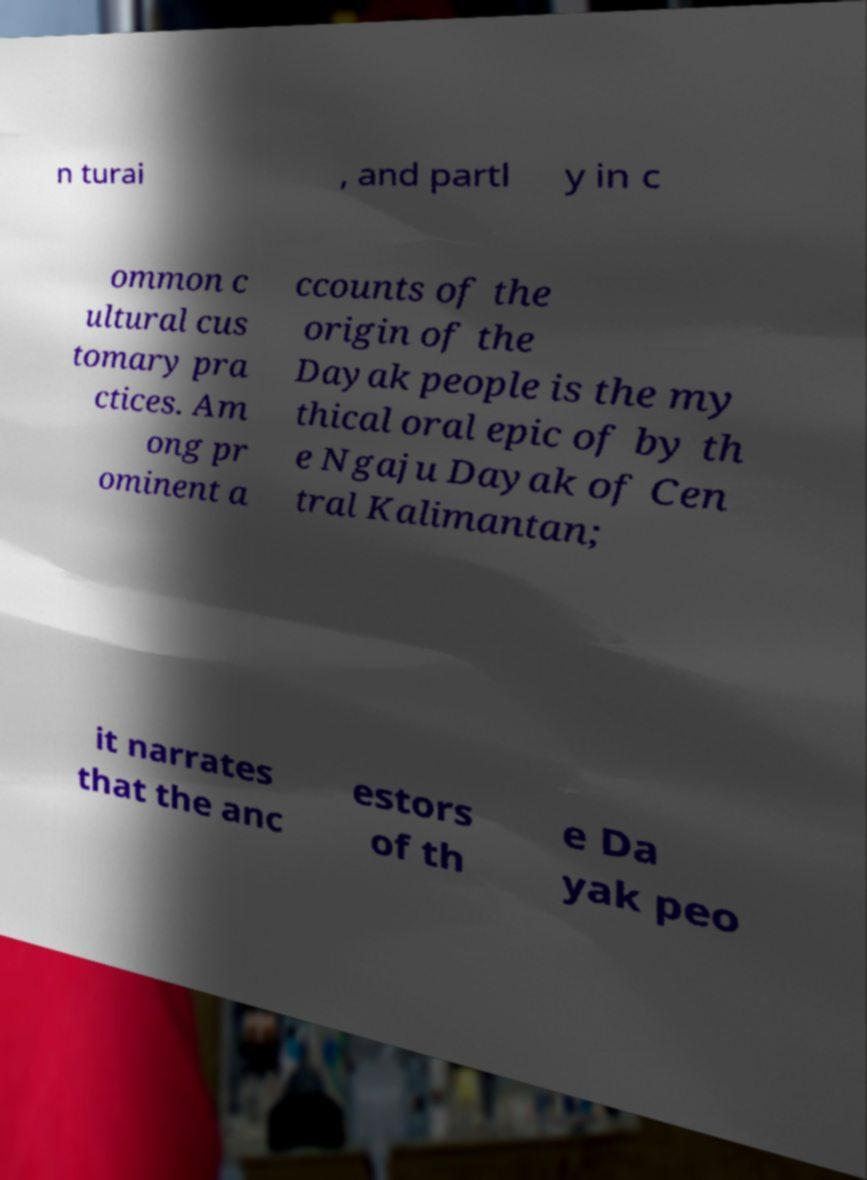I need the written content from this picture converted into text. Can you do that? n turai , and partl y in c ommon c ultural cus tomary pra ctices. Am ong pr ominent a ccounts of the origin of the Dayak people is the my thical oral epic of by th e Ngaju Dayak of Cen tral Kalimantan; it narrates that the anc estors of th e Da yak peo 